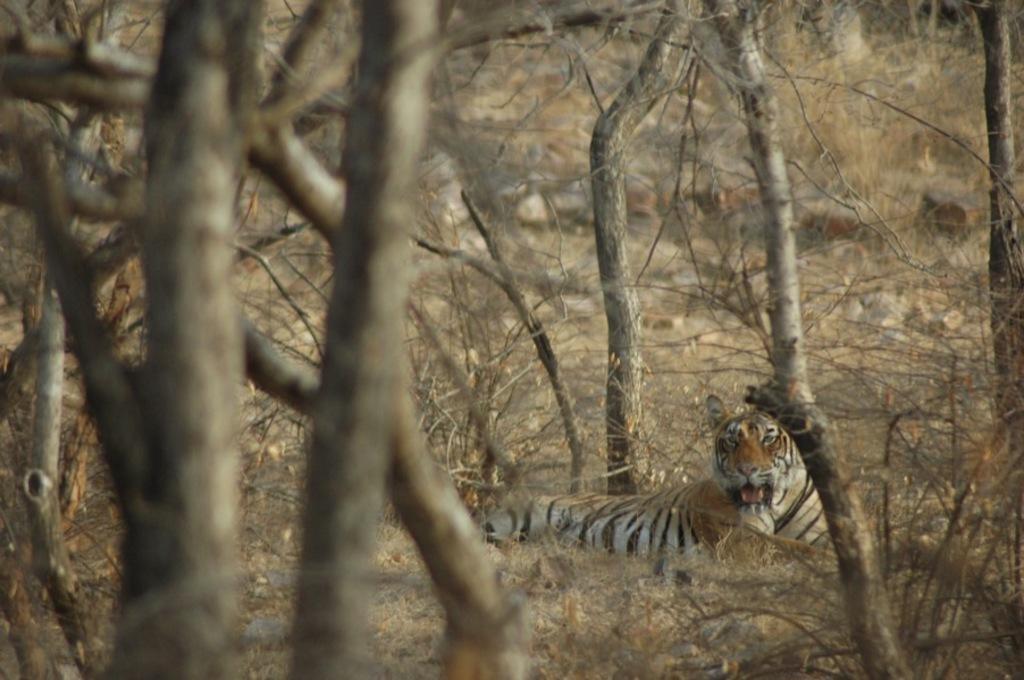How would you summarize this image in a sentence or two? In the center of the image we can see trees and a tiger. In the background, we can see it is blurred. 